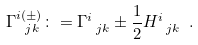Convert formula to latex. <formula><loc_0><loc_0><loc_500><loc_500>\Gamma ^ { i ( \pm ) } _ { \ j k } \colon = \Gamma ^ { i } _ { \ j k } \pm \frac { 1 } { 2 } H ^ { i } _ { \ j k } \ .</formula> 